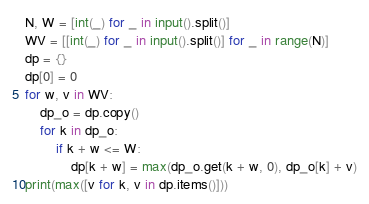<code> <loc_0><loc_0><loc_500><loc_500><_Python_>N, W = [int(_) for _ in input().split()]
WV = [[int(_) for _ in input().split()] for _ in range(N)]
dp = {}
dp[0] = 0
for w, v in WV:
    dp_o = dp.copy()
    for k in dp_o:
        if k + w <= W:
            dp[k + w] = max(dp_o.get(k + w, 0), dp_o[k] + v)
print(max([v for k, v in dp.items()]))
</code> 